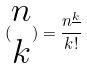Convert formula to latex. <formula><loc_0><loc_0><loc_500><loc_500>( \begin{matrix} n \\ k \end{matrix} ) = \frac { n ^ { \underline { k } } } { k ! }</formula> 